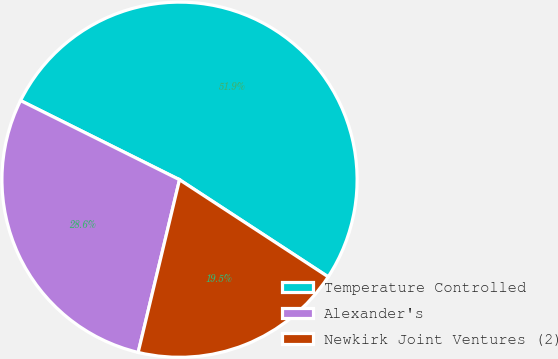<chart> <loc_0><loc_0><loc_500><loc_500><pie_chart><fcel>Temperature Controlled<fcel>Alexander's<fcel>Newkirk Joint Ventures (2)<nl><fcel>51.86%<fcel>28.61%<fcel>19.53%<nl></chart> 